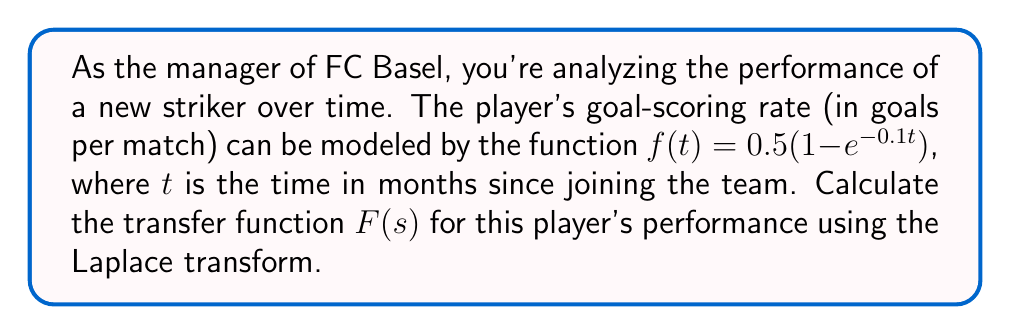Could you help me with this problem? To solve this problem, we need to apply the Laplace transform to the given function $f(t)$. Let's break it down step by step:

1) The Laplace transform of $f(t)$ is defined as:

   $$F(s) = \mathcal{L}\{f(t)\} = \int_0^\infty f(t)e^{-st}dt$$

2) Substituting our function $f(t) = 0.5(1 - e^{-0.1t})$:

   $$F(s) = \int_0^\infty 0.5(1 - e^{-0.1t})e^{-st}dt$$

3) We can split this integral:

   $$F(s) = 0.5\int_0^\infty e^{-st}dt - 0.5\int_0^\infty e^{-(s+0.1)t}dt$$

4) For the first integral:

   $$0.5\int_0^\infty e^{-st}dt = 0.5 \cdot \frac{1}{s}$$

5) For the second integral:

   $$-0.5\int_0^\infty e^{-(s+0.1)t}dt = -0.5 \cdot \frac{1}{s+0.1}$$

6) Combining the results:

   $$F(s) = 0.5 \cdot \frac{1}{s} - 0.5 \cdot \frac{1}{s+0.1}$$

7) Finding a common denominator:

   $$F(s) = 0.5 \cdot \frac{s+0.1}{s(s+0.1)} - 0.5 \cdot \frac{s}{s(s+0.1)}$$

8) Simplifying:

   $$F(s) = 0.5 \cdot \frac{0.1}{s(s+0.1)}$$

9) Final simplification:

   $$F(s) = \frac{0.05}{s(s+0.1)}$$

This is the transfer function for the player's performance over time.
Answer: $$F(s) = \frac{0.05}{s(s+0.1)}$$ 